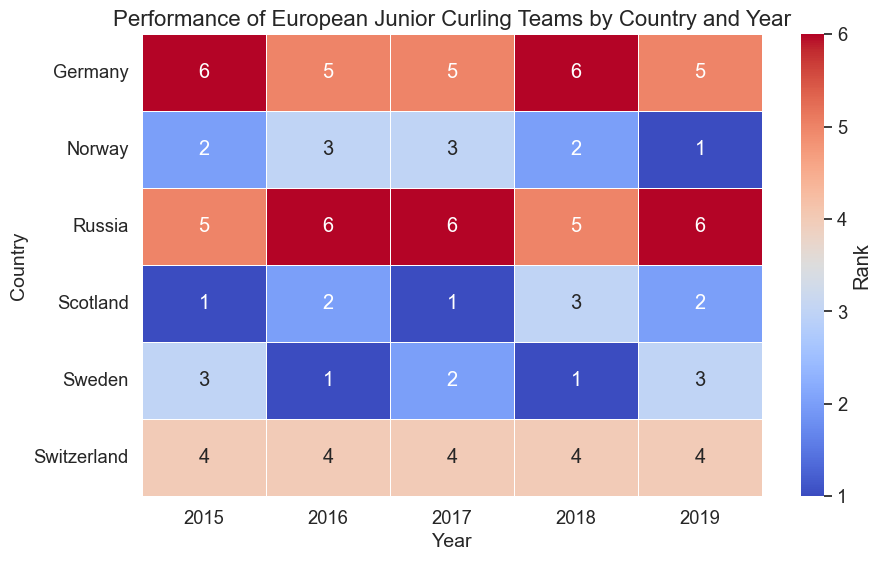Which country had the highest rank in 2019? To identify the highest rank in 2019, scan the column for 2019. The rank values are: Scotland (2), Sweden (3), Norway (1), Switzerland (4), Germany (5), and Russia (6). The lowest number indicates the highest rank. Norway had the rank of 1 in 2019.
Answer: Norway Which country showed the most improvement in rank from 2018 to 2019? To determine the most improvement, calculate the difference in ranks for each country between 2018 and 2019. Scotland moved from rank 3 to 2 (change of -1), Sweden from 1 to 3 (change of +2), Norway from 2 to 1 (change of -1), Switzerland remained at 4, Germany moved from 6 to 5 (change of -1), and Russia moved from 5 to 6 (change of +1). Sweden showed the highest positive change in rank.
Answer: Germany How many times did Switzerland rank 4th in the given years? Check the figure for Switzerland’s rank over the years 2015 to 2019. Switzerland has consistently ranked 4th each year: 2015 (4), 2016 (4), 2017 (4), 2018 (4), and 2019 (4). Count the number of occurrences.
Answer: 5 Which year saw the highest rank for Sweden? Look at Sweden’s ranks over the years: 2015 (3), 2016 (1), 2017 (2), 2018 (1), and 2019 (3). The highest rank is 1, which appeared in 2016 and 2018.
Answer: 2016 and 2018 Which country had the lowest average rank across all years? Calculate the average rank for each country by summing their ranks over the years and dividing by the number of years (5). Scotland: (1+2+1+3+2)/5 = 1.8, Sweden: (3+1+2+1+3)/5 = 2, Norway: (2+3+3+2+1)/5 = 2.2, Switzerland: (4+4+4+4+4)/5 = 4, Germany: (6+5+5+6+5)/5 = 5.4, Russia: (5+6+6+5+6)/5 = 5.6. The lowest average rank is for Scotland.
Answer: Scotland Which country showed the least variation in their ranking positions? To assess the variation, observe the consistency of ranks for each country across all years. Scotland's ranks: (1, 2, 1, 3, 2), Sweden's ranks: (3, 1, 2, 1, 3), Norway's ranks: (2, 3, 3, 2, 1), Switzerland’s ranks: (4, 4, 4, 4, 4), Germany's ranks: (6, 5, 5, 6, 5), Russia's ranks: (5, 6, 6, 5, 6). Switzerland remained constant with a rank of 4.
Answer: Switzerland How many countries had at least one rank 1 during these years? Verify each country’s ranks over the years for the number 1. Scotland (2 ranks of 1), Sweden (2 ranks of 1), Norway (1 rank of 1), Switzerland (0 ranks of 1), Germany (0 ranks of 1), Russia (0 ranks of 1).
Answer: 3 Between 2015 and 2019, which country improved the most? Compare the rank of each country in 2015 with that in 2019: Scotland (1 to 2, change of +1), Sweden (3 to 3, no change), Norway (2 to 1, change of -1), Switzerland (4 to 4, no change), Germany (6 to 5, change of -1), Russia (5 to 6, change of +1). Norway and Germany improved the most.
Answer: Norway and Germany What is the average rank of Germany from 2015 to 2019? Sum Germany’s ranks and divide by the number of years: (6+5+5+6+5)/5 = 5.4.
Answer: 5.4 